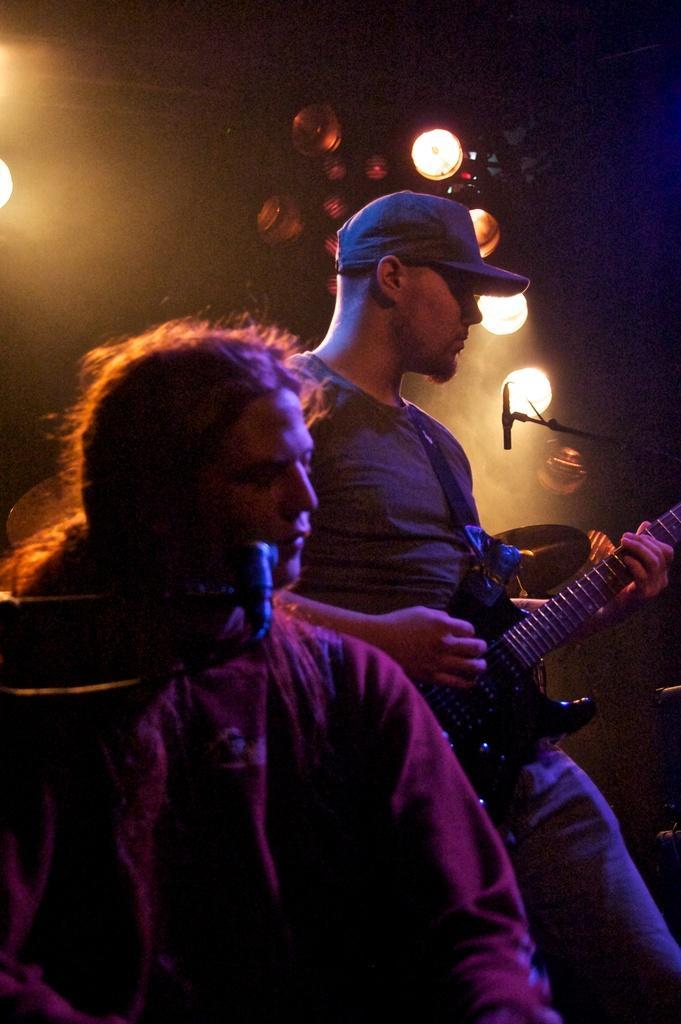Can you describe this image briefly? This image is taken in a concert. There are two people in this image. At the top of the image there are few lights. In the right side of the image a man is standing and holding a guitar in his hand. In the left side of the image a woman is singing. 